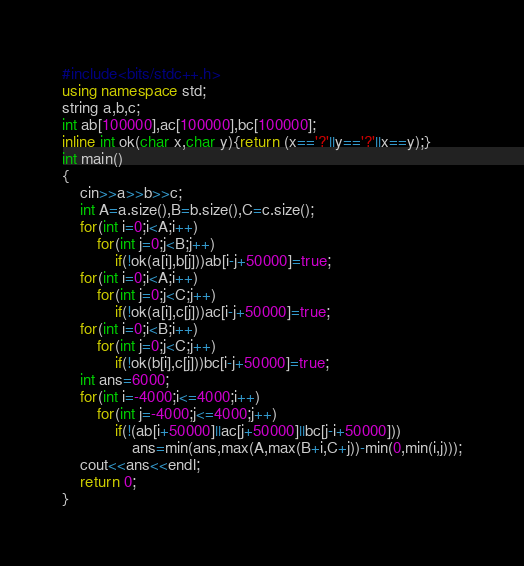<code> <loc_0><loc_0><loc_500><loc_500><_C++_>#include<bits/stdc++.h>
using namespace std;
string a,b,c;
int ab[100000],ac[100000],bc[100000];
inline int ok(char x,char y){return (x=='?'||y=='?'||x==y);}
int main()
{
	cin>>a>>b>>c;
	int A=a.size(),B=b.size(),C=c.size();
	for(int i=0;i<A;i++)
		for(int j=0;j<B;j++)
			if(!ok(a[i],b[j]))ab[i-j+50000]=true;
	for(int i=0;i<A;i++)
		for(int j=0;j<C;j++)
			if(!ok(a[i],c[j]))ac[i-j+50000]=true;
	for(int i=0;i<B;i++)
		for(int j=0;j<C;j++)
			if(!ok(b[i],c[j]))bc[i-j+50000]=true;
	int ans=6000;
	for(int i=-4000;i<=4000;i++)
		for(int j=-4000;j<=4000;j++)
			if(!(ab[i+50000]||ac[j+50000]||bc[j-i+50000]))	
				ans=min(ans,max(A,max(B+i,C+j))-min(0,min(i,j)));
	cout<<ans<<endl;
	return 0;
}</code> 